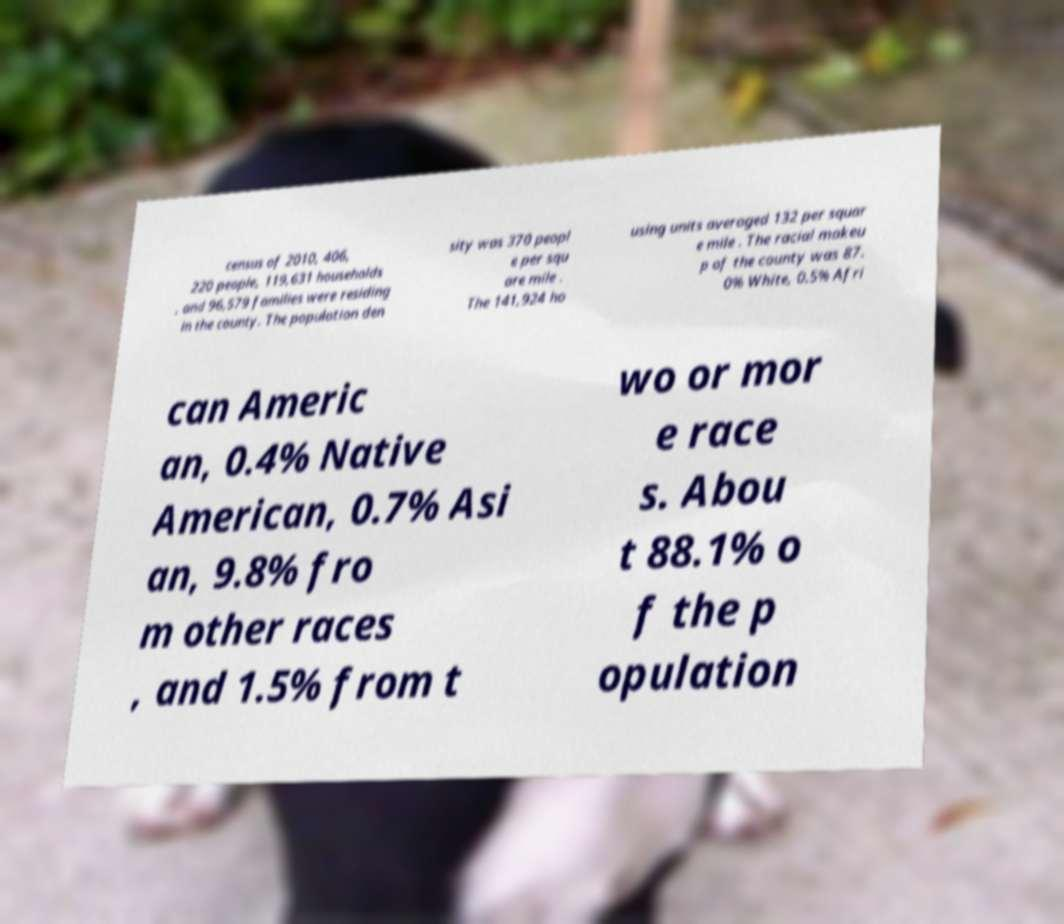I need the written content from this picture converted into text. Can you do that? census of 2010, 406, 220 people, 119,631 households , and 96,579 families were residing in the county. The population den sity was 370 peopl e per squ are mile . The 141,924 ho using units averaged 132 per squar e mile . The racial makeu p of the county was 87. 0% White, 0.5% Afri can Americ an, 0.4% Native American, 0.7% Asi an, 9.8% fro m other races , and 1.5% from t wo or mor e race s. Abou t 88.1% o f the p opulation 